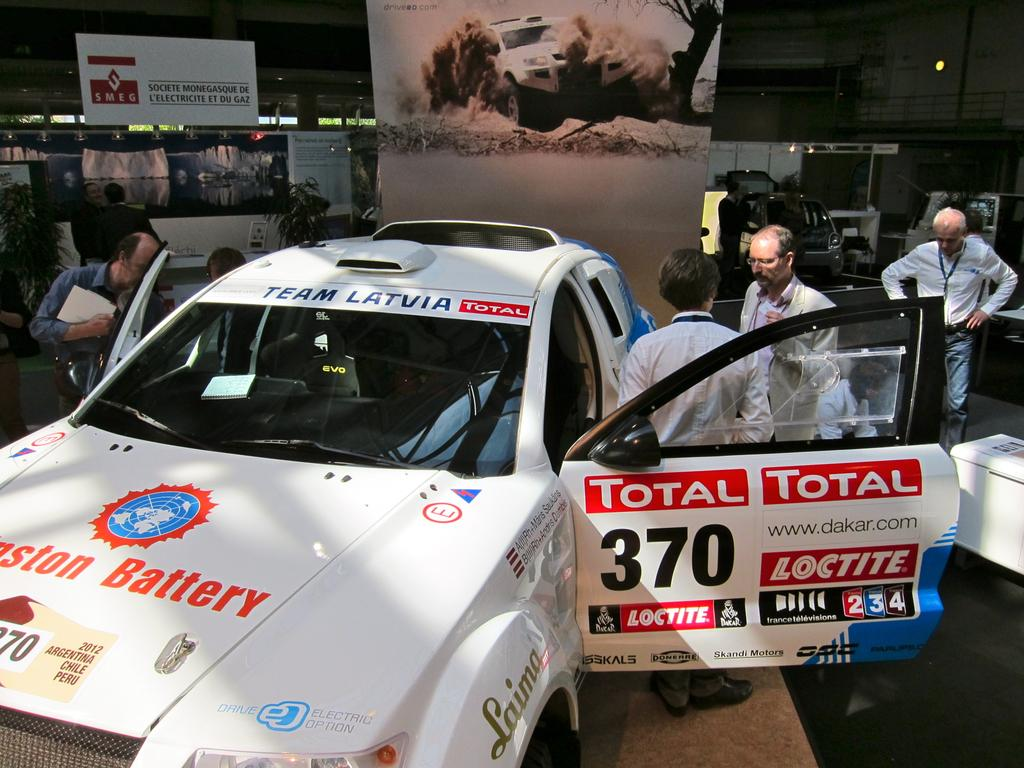What is hanging or displayed in the image? There is a banner in the image. What type of vehicle is present in the image? There is a car in the image. Can you describe the people in the image? There are people standing in the image. What type of books can be seen stacked on the car in the image? There are no books present in the image, and the car is not stacked with any books. What kind of curve can be observed in the image? There is no curve present in the image; it features a banner, a car, and people standing. 